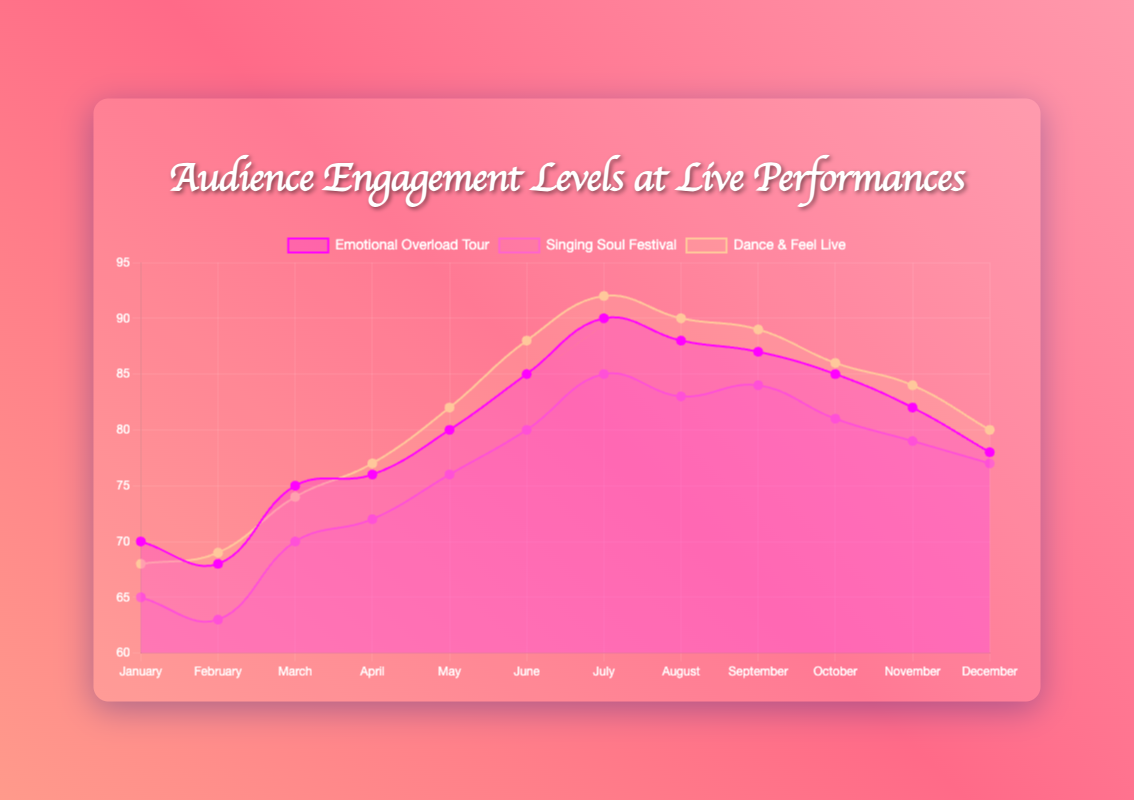What is the title of the figure? The title of the figure is prominently displayed at the top. Readers can easily spot it.
Answer: Audience Engagement Levels at Live Performances Which tour shows the highest engagement level in July? By looking at the month of July on the x-axis, check which of the three lines reaches the highest point.
Answer: Dance & Feel Live In what month did the Singing Soul Festival have the lowest engagement level? Identify the month on the x-axis where the line representing the Singing Soul Festival dips the lowest.
Answer: February What is the general trend of engagement levels for the Emotional Overload Tour from January to December? Observe the line representing the Emotional Overload Tour. Track its movement from January to December along the x-axis.
Answer: Increasing until July, then decreasing How does the engagement level of Dance & Feel Live in December compare to that in June? Locate the points for Dance & Feel Live in December and June. Compare their heights on the y-axis.
Answer: Lower in December than June Which tour had the highest average engagement level over the entire year? Calculate the yearly average by summing the engagement levels for each tour and dividing by 12. Compare the averages.
Answer: Dance & Feel Live In which months does Dance & Feel Live have higher engagement levels than both the other tours? Identify months where the line for Dance & Feel Live is consistently above the other two lines.
Answer: June, July, August, September, October, November, December What is the difference in engagement levels between February and November for the Singing Soul Festival? Subtract the February engagement level of the Singing Soul Festival from its November engagement level.
Answer: 16 Which two months see the biggest drop in engagement levels for Emotional Overload Tour? Look for two consecutive months where the line for Emotional Overload Tour drops the most sharply.
Answer: July to August Overall, which tour has the most fluctuating engagement levels throughout the year? Compare the variability of the engagement levels for each tour by examining the ups and downs of each line.
Answer: Dance & Feel Live 